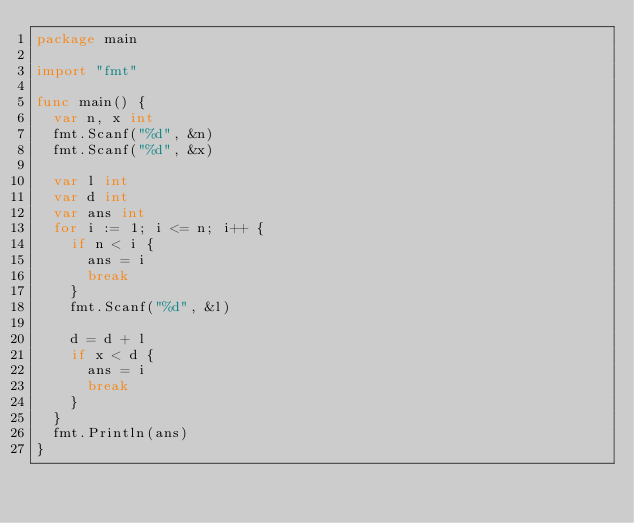Convert code to text. <code><loc_0><loc_0><loc_500><loc_500><_Go_>package main

import "fmt"

func main() {
	var n, x int
	fmt.Scanf("%d", &n)
	fmt.Scanf("%d", &x)

	var l int
	var d int
	var ans int
	for i := 1; i <= n; i++ {
		if n < i {
			ans = i
			break
		}
		fmt.Scanf("%d", &l)

		d = d + l
		if x < d {
			ans = i
			break
		}
	}
	fmt.Println(ans)
}
</code> 